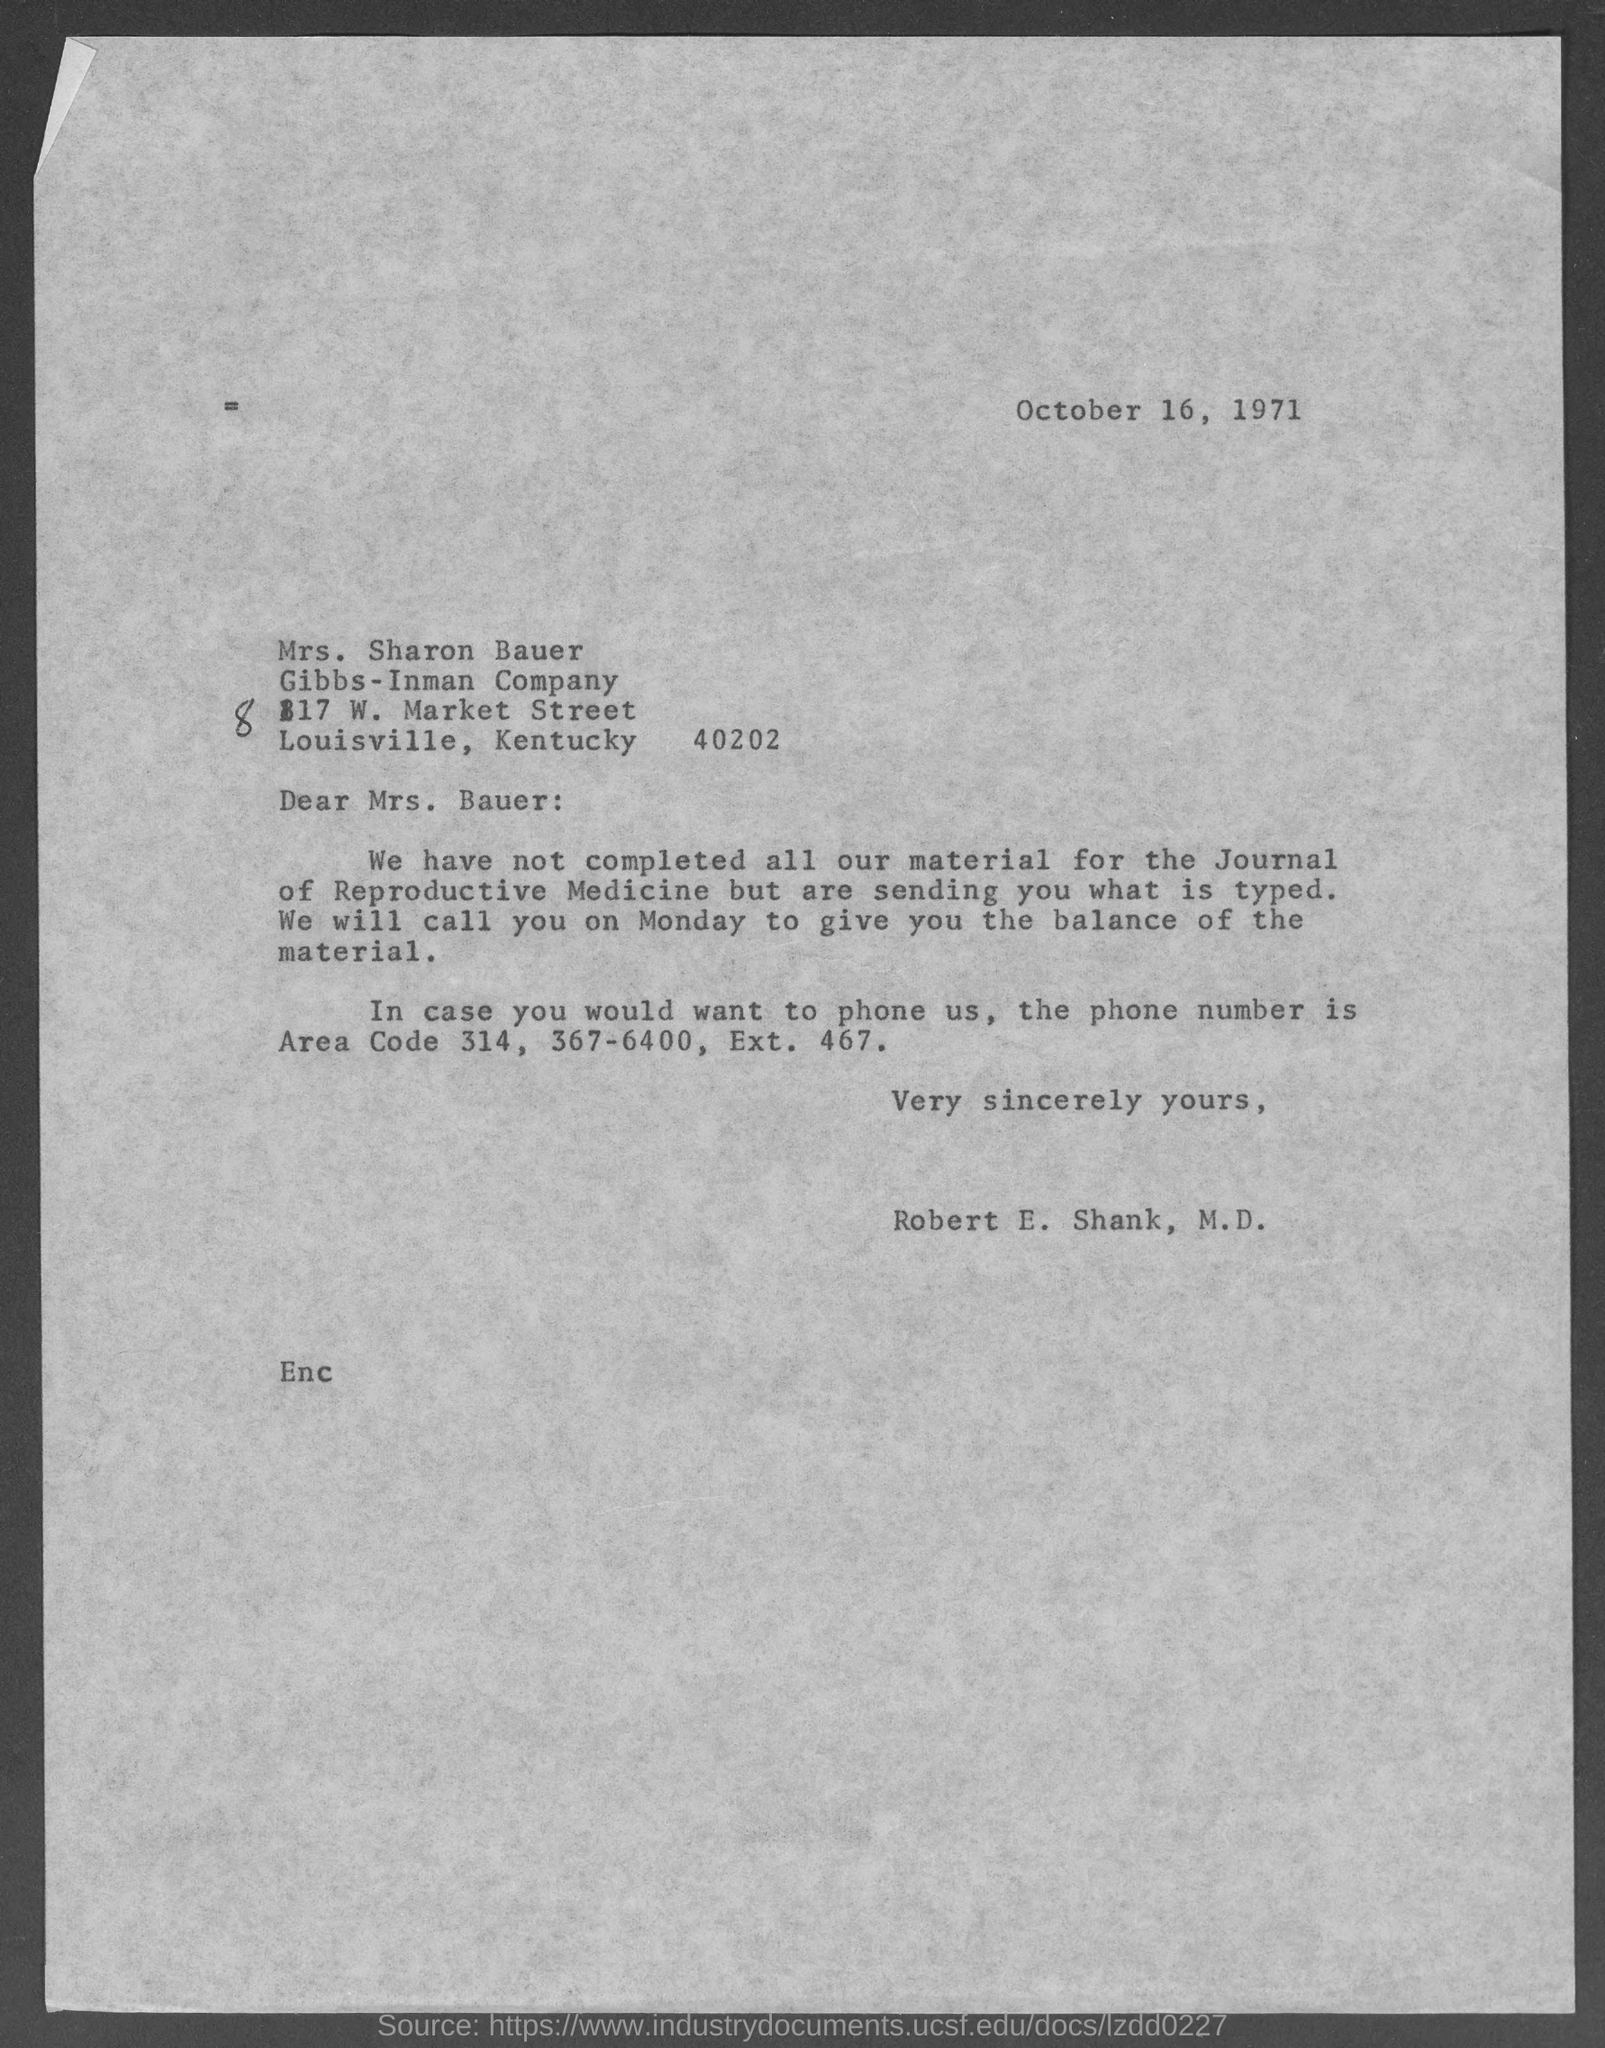What is the date mentioned in the top of the document ?
Offer a terse response. October 16, 1971. Who is the Memorandum addressed to ?
Provide a succinct answer. Mrs. Bauer. 